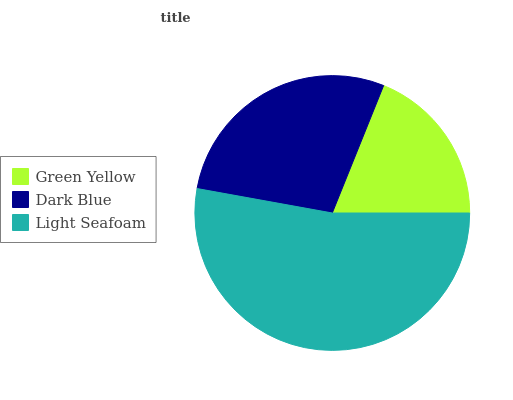Is Green Yellow the minimum?
Answer yes or no. Yes. Is Light Seafoam the maximum?
Answer yes or no. Yes. Is Dark Blue the minimum?
Answer yes or no. No. Is Dark Blue the maximum?
Answer yes or no. No. Is Dark Blue greater than Green Yellow?
Answer yes or no. Yes. Is Green Yellow less than Dark Blue?
Answer yes or no. Yes. Is Green Yellow greater than Dark Blue?
Answer yes or no. No. Is Dark Blue less than Green Yellow?
Answer yes or no. No. Is Dark Blue the high median?
Answer yes or no. Yes. Is Dark Blue the low median?
Answer yes or no. Yes. Is Light Seafoam the high median?
Answer yes or no. No. Is Green Yellow the low median?
Answer yes or no. No. 